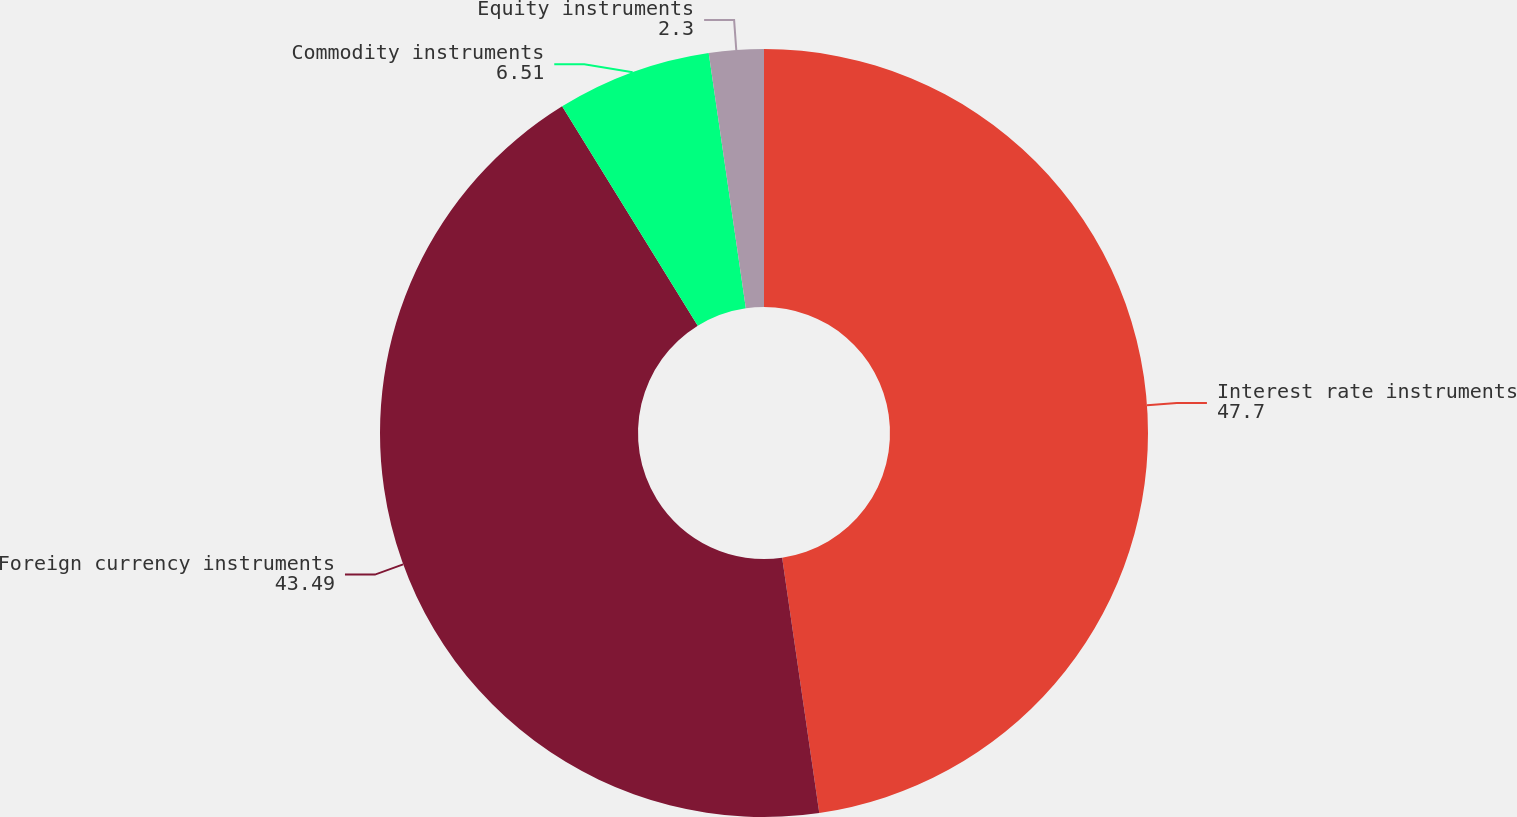<chart> <loc_0><loc_0><loc_500><loc_500><pie_chart><fcel>Interest rate instruments<fcel>Foreign currency instruments<fcel>Commodity instruments<fcel>Equity instruments<nl><fcel>47.7%<fcel>43.49%<fcel>6.51%<fcel>2.3%<nl></chart> 